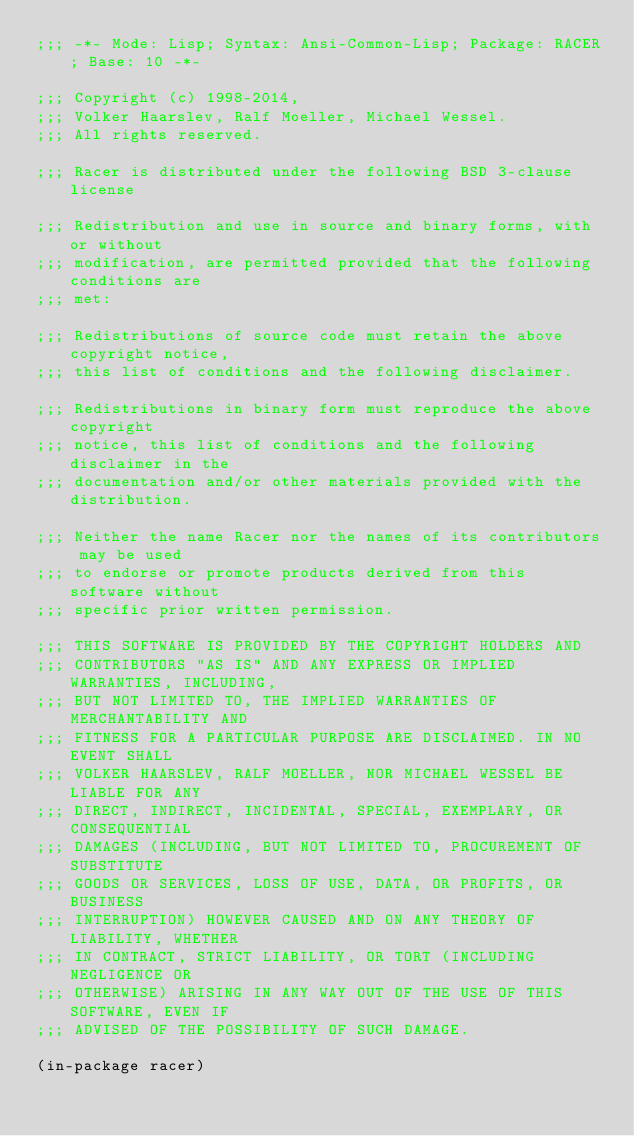<code> <loc_0><loc_0><loc_500><loc_500><_Lisp_>;;; -*- Mode: Lisp; Syntax: Ansi-Common-Lisp; Package: RACER; Base: 10 -*-

;;; Copyright (c) 1998-2014, 
;;; Volker Haarslev, Ralf Moeller, Michael Wessel.  
;;; All rights reserved.

;;; Racer is distributed under the following BSD 3-clause license

;;; Redistribution and use in source and binary forms, with or without
;;; modification, are permitted provided that the following conditions are
;;; met:

;;; Redistributions of source code must retain the above copyright notice,
;;; this list of conditions and the following disclaimer.

;;; Redistributions in binary form must reproduce the above copyright
;;; notice, this list of conditions and the following disclaimer in the
;;; documentation and/or other materials provided with the distribution.

;;; Neither the name Racer nor the names of its contributors may be used
;;; to endorse or promote products derived from this software without
;;; specific prior written permission.

;;; THIS SOFTWARE IS PROVIDED BY THE COPYRIGHT HOLDERS AND
;;; CONTRIBUTORS "AS IS" AND ANY EXPRESS OR IMPLIED WARRANTIES, INCLUDING,
;;; BUT NOT LIMITED TO, THE IMPLIED WARRANTIES OF MERCHANTABILITY AND
;;; FITNESS FOR A PARTICULAR PURPOSE ARE DISCLAIMED. IN NO EVENT SHALL
;;; VOLKER HAARSLEV, RALF MOELLER, NOR MICHAEL WESSEL BE LIABLE FOR ANY
;;; DIRECT, INDIRECT, INCIDENTAL, SPECIAL, EXEMPLARY, OR CONSEQUENTIAL
;;; DAMAGES (INCLUDING, BUT NOT LIMITED TO, PROCUREMENT OF SUBSTITUTE
;;; GOODS OR SERVICES, LOSS OF USE, DATA, OR PROFITS, OR BUSINESS
;;; INTERRUPTION) HOWEVER CAUSED AND ON ANY THEORY OF LIABILITY, WHETHER
;;; IN CONTRACT, STRICT LIABILITY, OR TORT (INCLUDING NEGLIGENCE OR
;;; OTHERWISE) ARISING IN ANY WAY OUT OF THE USE OF THIS SOFTWARE, EVEN IF
;;; ADVISED OF THE POSSIBILITY OF SUCH DAMAGE.

(in-package racer)
</code> 